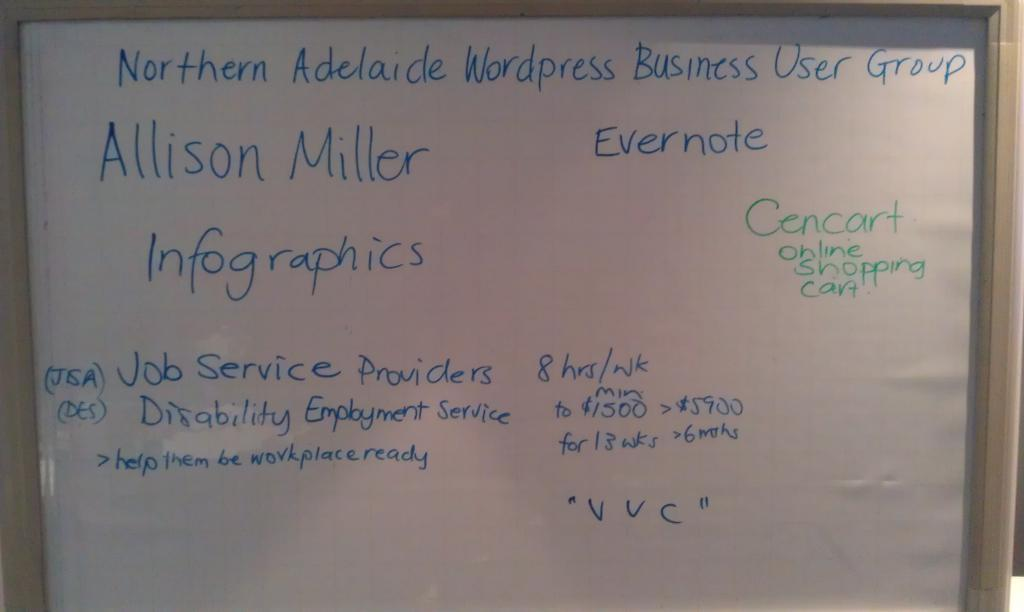What is the main object in the image? There is a white color board in the image. What is visible on the white color board? There is something written on the board. Can you see any islands or geese in the image? No, there are no islands or geese present in the image. What type of leaf is depicted on the white color board? There is no leaf depicted on the white color board; it only has something written on it. 